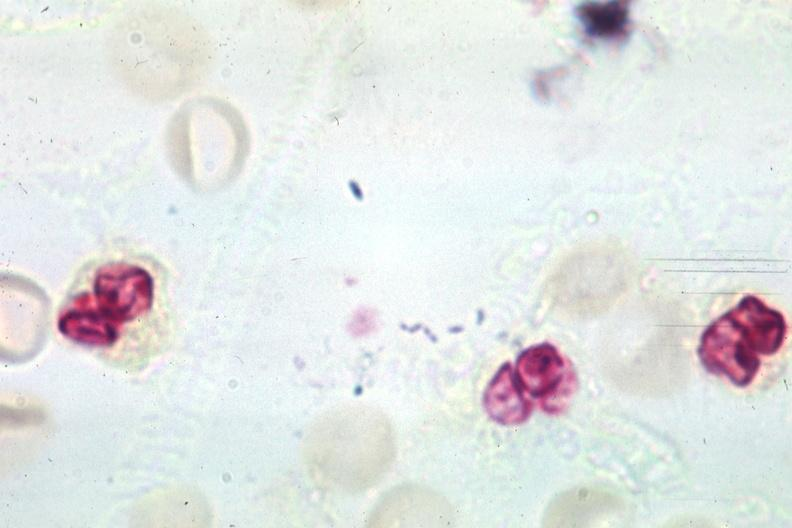what is present?
Answer the question using a single word or phrase. Neutrophil gram positive diplococci 